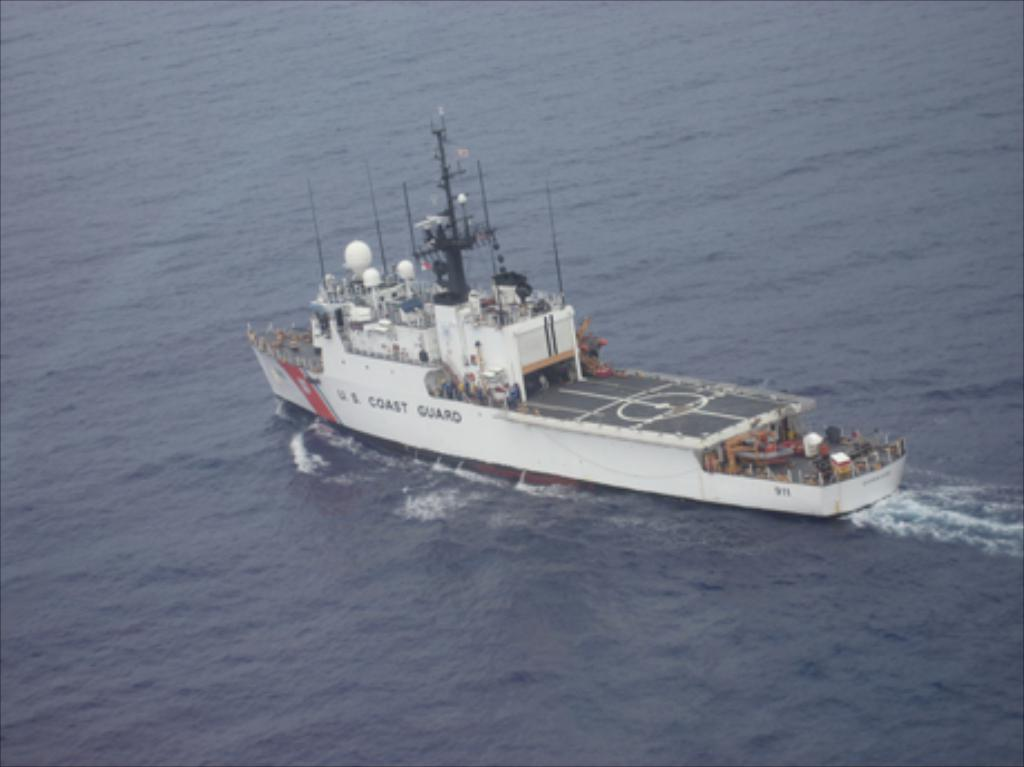What is the main subject in the center of the image? There is a ship in the center of the image. Where is the ship located? The ship is on the water. What can be seen around the area of the image? There is water visible around the area of the image. Can you see the ship taking a bath in the image? No, there is no indication of the ship taking a bath in the image. 